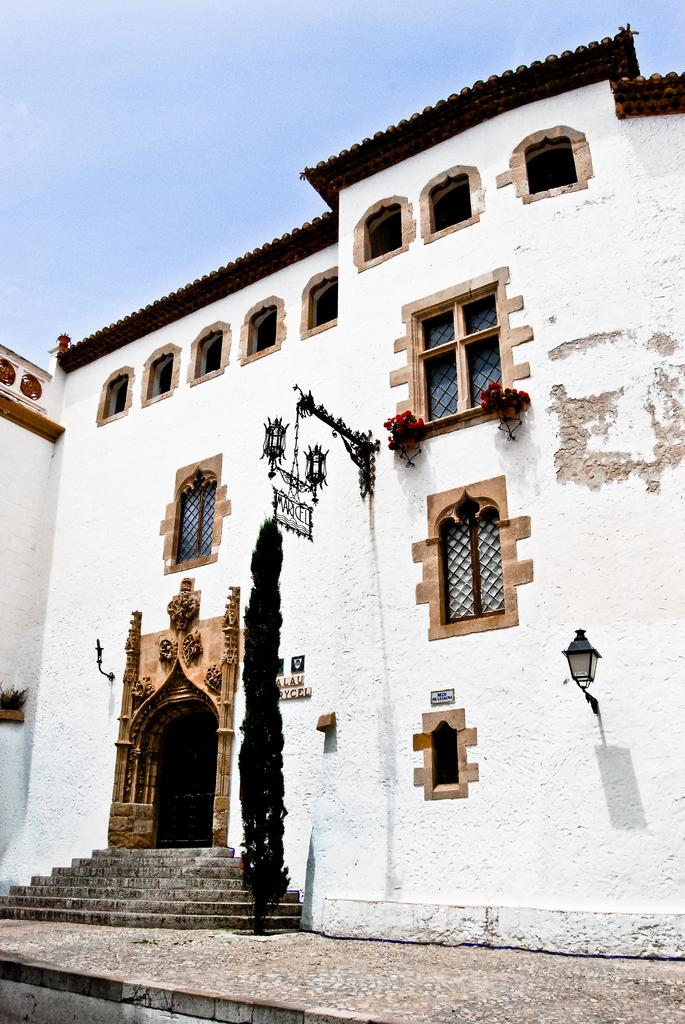What is the color of the building in the image? The building in the image is white. What type of vegetation is present in the image? There is a small tree in the image. What is the color of the windows on the building? The windows on the building are brown. How can someone enter the building? There is an entrance to the building. What can be seen in the background of the image? The sky is visible in the background of the image. What type of plastic material is used to make the floor in the image? There is no information about the floor in the image, and no mention of plastic material. 